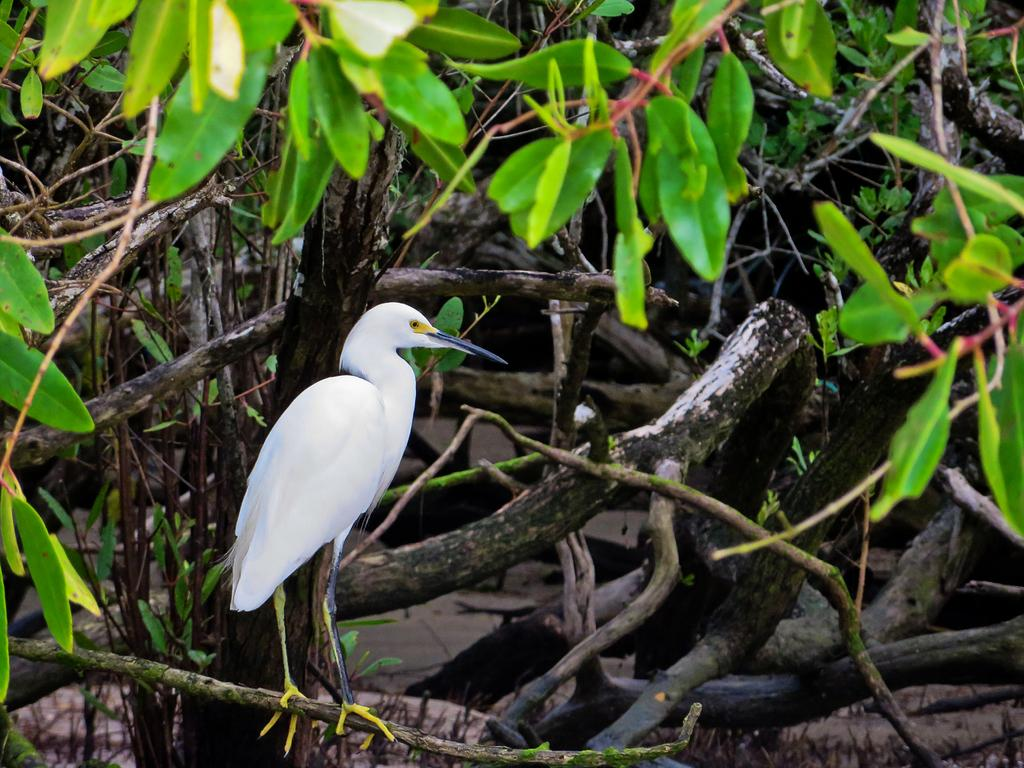What is the main subject of the image? The main subject of the image is a crane. Where is the crane located in the image? The crane is on a steam in the image. What can be seen in the background of the image? There are trees in the background of the image. What type of yam is being used to support the crane in the image? There is no yam present in the image, and the crane is not supported by any yam. 